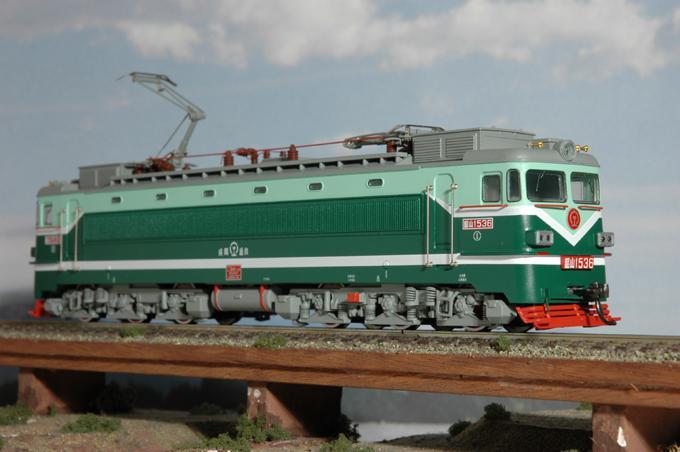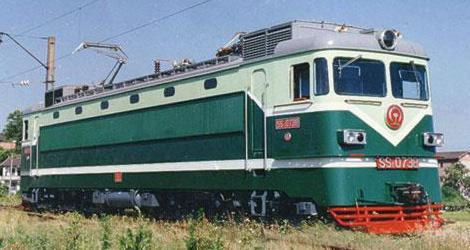The first image is the image on the left, the second image is the image on the right. Assess this claim about the two images: "Both trains are primarily green and moving toward the right.". Correct or not? Answer yes or no. Yes. The first image is the image on the left, the second image is the image on the right. Analyze the images presented: Is the assertion "All trains are greenish in color and heading rightward at an angle." valid? Answer yes or no. Yes. 